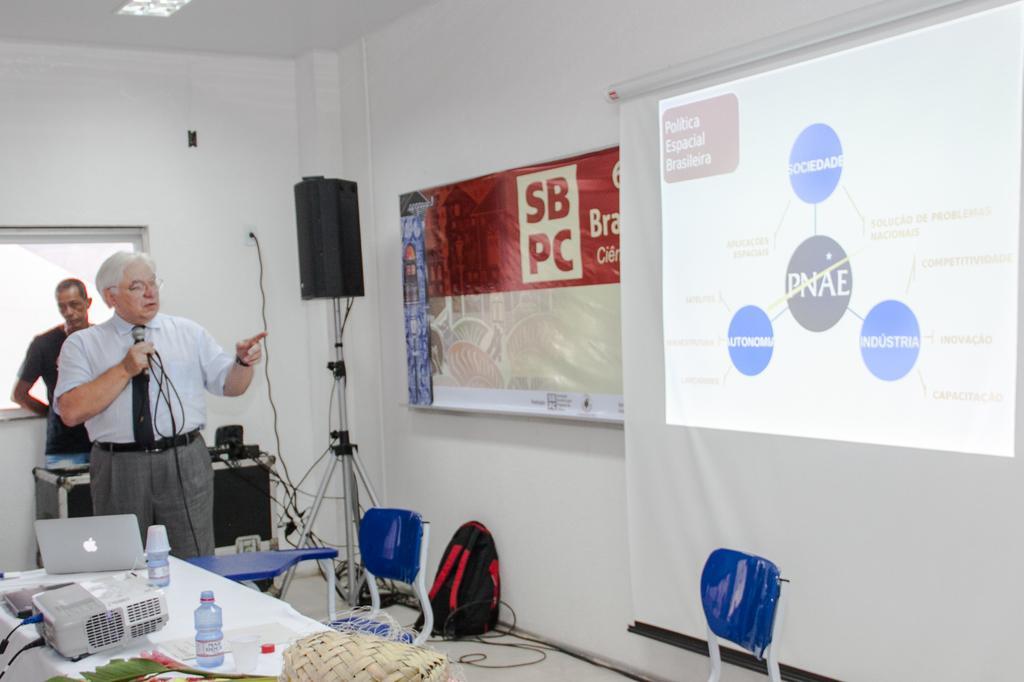Could you give a brief overview of what you see in this image? This picture is clicked in the conference hall. At the bottom, we see a table on which the laptops, projector, glass bottles, glasses and a basket are placed. Beside that, we see a blue color table and a chair. On the right side, we see a chair and a projector screen which is displaying some text. Beside that, we see a banner in white, red and blue color. Beside that, we see a speaker box and a bag in black color. On the left side, we see a man is standing and he is holding a microphone in his hand and I think he is talking on the microphone. Behind him, we see a black table on which black color objects are placed. Beside that, we see a man is standing. In the background, we see a white wall and a window. 